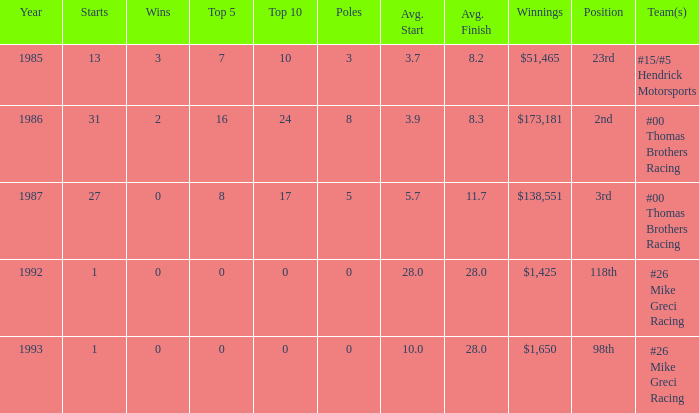7? 1.0. 